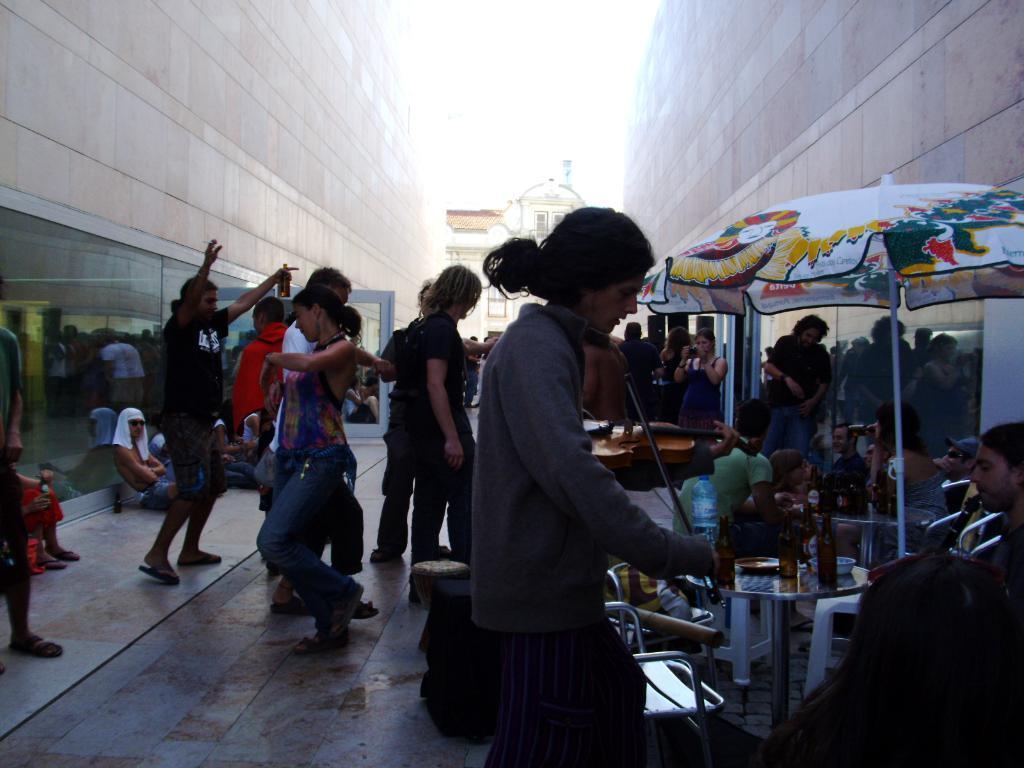How would you summarize this image in a sentence or two? In the foreground of this image, there is a person playing violin and on the right bottom, there is a person´s head and we can also see a man playing clarinet, under an umbrella and there is a table on which bottles, bowl are on it and also there are persons sitting, dancing, shooting with a camera, standing in between two walls and a building in the background. On the top, there is a sunny sky. 